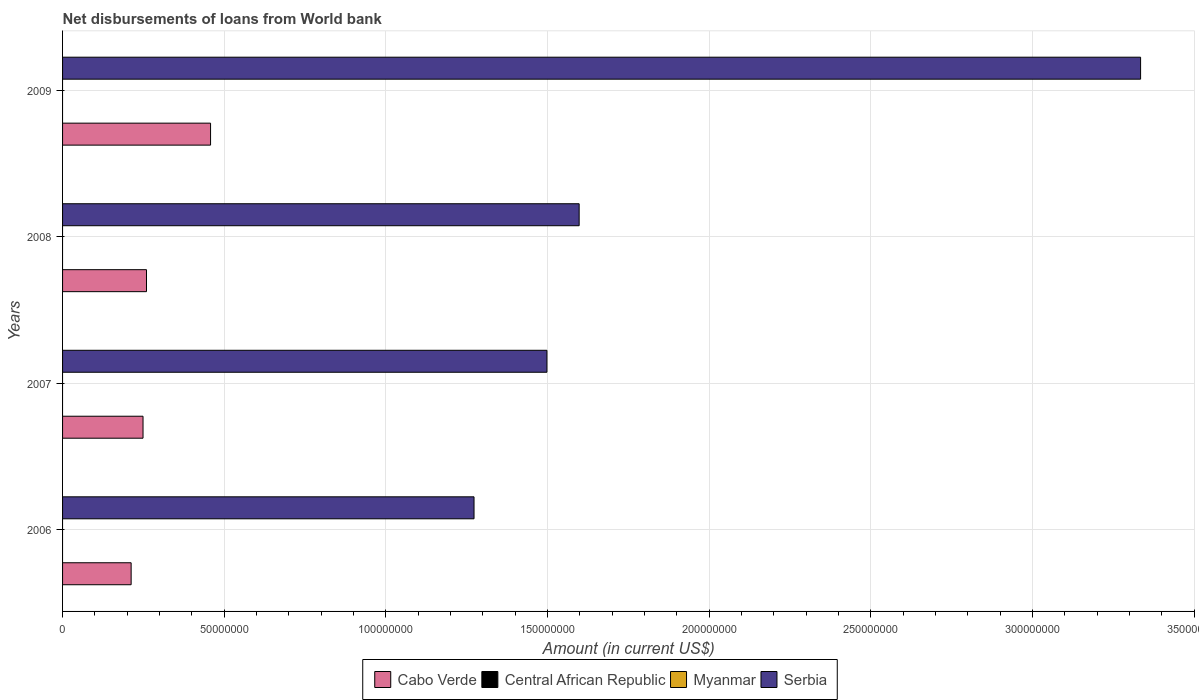Are the number of bars per tick equal to the number of legend labels?
Keep it short and to the point. No. Are the number of bars on each tick of the Y-axis equal?
Provide a succinct answer. Yes. How many bars are there on the 2nd tick from the bottom?
Your response must be concise. 2. What is the label of the 4th group of bars from the top?
Your answer should be very brief. 2006. What is the amount of loan disbursed from World Bank in Central African Republic in 2008?
Give a very brief answer. 0. Across all years, what is the maximum amount of loan disbursed from World Bank in Cabo Verde?
Your response must be concise. 4.58e+07. In which year was the amount of loan disbursed from World Bank in Serbia maximum?
Offer a terse response. 2009. What is the total amount of loan disbursed from World Bank in Cabo Verde in the graph?
Give a very brief answer. 1.18e+08. What is the difference between the amount of loan disbursed from World Bank in Serbia in 2007 and that in 2008?
Your answer should be very brief. -9.97e+06. What is the difference between the amount of loan disbursed from World Bank in Cabo Verde in 2006 and the amount of loan disbursed from World Bank in Central African Republic in 2009?
Keep it short and to the point. 2.12e+07. In the year 2009, what is the difference between the amount of loan disbursed from World Bank in Serbia and amount of loan disbursed from World Bank in Cabo Verde?
Offer a terse response. 2.88e+08. What is the ratio of the amount of loan disbursed from World Bank in Cabo Verde in 2007 to that in 2009?
Make the answer very short. 0.54. Is the amount of loan disbursed from World Bank in Serbia in 2008 less than that in 2009?
Your answer should be compact. Yes. Is the difference between the amount of loan disbursed from World Bank in Serbia in 2007 and 2008 greater than the difference between the amount of loan disbursed from World Bank in Cabo Verde in 2007 and 2008?
Your answer should be compact. No. What is the difference between the highest and the second highest amount of loan disbursed from World Bank in Serbia?
Your answer should be very brief. 1.74e+08. What is the difference between the highest and the lowest amount of loan disbursed from World Bank in Cabo Verde?
Ensure brevity in your answer.  2.46e+07. Is it the case that in every year, the sum of the amount of loan disbursed from World Bank in Serbia and amount of loan disbursed from World Bank in Myanmar is greater than the amount of loan disbursed from World Bank in Cabo Verde?
Give a very brief answer. Yes. How many bars are there?
Ensure brevity in your answer.  8. How many years are there in the graph?
Your answer should be very brief. 4. What is the difference between two consecutive major ticks on the X-axis?
Provide a short and direct response. 5.00e+07. Are the values on the major ticks of X-axis written in scientific E-notation?
Your answer should be compact. No. Does the graph contain any zero values?
Provide a short and direct response. Yes. Where does the legend appear in the graph?
Provide a succinct answer. Bottom center. How are the legend labels stacked?
Your answer should be very brief. Horizontal. What is the title of the graph?
Offer a very short reply. Net disbursements of loans from World bank. Does "French Polynesia" appear as one of the legend labels in the graph?
Your answer should be very brief. No. What is the label or title of the X-axis?
Offer a terse response. Amount (in current US$). What is the Amount (in current US$) of Cabo Verde in 2006?
Give a very brief answer. 2.12e+07. What is the Amount (in current US$) in Central African Republic in 2006?
Offer a terse response. 0. What is the Amount (in current US$) of Myanmar in 2006?
Provide a short and direct response. 0. What is the Amount (in current US$) in Serbia in 2006?
Give a very brief answer. 1.27e+08. What is the Amount (in current US$) in Cabo Verde in 2007?
Your answer should be compact. 2.49e+07. What is the Amount (in current US$) in Myanmar in 2007?
Ensure brevity in your answer.  0. What is the Amount (in current US$) of Serbia in 2007?
Ensure brevity in your answer.  1.50e+08. What is the Amount (in current US$) in Cabo Verde in 2008?
Your response must be concise. 2.60e+07. What is the Amount (in current US$) in Myanmar in 2008?
Your answer should be very brief. 0. What is the Amount (in current US$) of Serbia in 2008?
Your answer should be very brief. 1.60e+08. What is the Amount (in current US$) in Cabo Verde in 2009?
Provide a short and direct response. 4.58e+07. What is the Amount (in current US$) of Serbia in 2009?
Your answer should be compact. 3.33e+08. Across all years, what is the maximum Amount (in current US$) of Cabo Verde?
Provide a succinct answer. 4.58e+07. Across all years, what is the maximum Amount (in current US$) of Serbia?
Give a very brief answer. 3.33e+08. Across all years, what is the minimum Amount (in current US$) in Cabo Verde?
Provide a succinct answer. 2.12e+07. Across all years, what is the minimum Amount (in current US$) of Serbia?
Provide a succinct answer. 1.27e+08. What is the total Amount (in current US$) in Cabo Verde in the graph?
Ensure brevity in your answer.  1.18e+08. What is the total Amount (in current US$) in Myanmar in the graph?
Give a very brief answer. 0. What is the total Amount (in current US$) of Serbia in the graph?
Your answer should be compact. 7.70e+08. What is the difference between the Amount (in current US$) of Cabo Verde in 2006 and that in 2007?
Make the answer very short. -3.68e+06. What is the difference between the Amount (in current US$) in Serbia in 2006 and that in 2007?
Give a very brief answer. -2.25e+07. What is the difference between the Amount (in current US$) of Cabo Verde in 2006 and that in 2008?
Make the answer very short. -4.75e+06. What is the difference between the Amount (in current US$) in Serbia in 2006 and that in 2008?
Keep it short and to the point. -3.25e+07. What is the difference between the Amount (in current US$) of Cabo Verde in 2006 and that in 2009?
Keep it short and to the point. -2.46e+07. What is the difference between the Amount (in current US$) of Serbia in 2006 and that in 2009?
Provide a short and direct response. -2.06e+08. What is the difference between the Amount (in current US$) in Cabo Verde in 2007 and that in 2008?
Ensure brevity in your answer.  -1.08e+06. What is the difference between the Amount (in current US$) in Serbia in 2007 and that in 2008?
Give a very brief answer. -9.97e+06. What is the difference between the Amount (in current US$) in Cabo Verde in 2007 and that in 2009?
Provide a short and direct response. -2.09e+07. What is the difference between the Amount (in current US$) of Serbia in 2007 and that in 2009?
Make the answer very short. -1.84e+08. What is the difference between the Amount (in current US$) in Cabo Verde in 2008 and that in 2009?
Your answer should be very brief. -1.98e+07. What is the difference between the Amount (in current US$) in Serbia in 2008 and that in 2009?
Give a very brief answer. -1.74e+08. What is the difference between the Amount (in current US$) in Cabo Verde in 2006 and the Amount (in current US$) in Serbia in 2007?
Offer a terse response. -1.29e+08. What is the difference between the Amount (in current US$) of Cabo Verde in 2006 and the Amount (in current US$) of Serbia in 2008?
Offer a terse response. -1.39e+08. What is the difference between the Amount (in current US$) in Cabo Verde in 2006 and the Amount (in current US$) in Serbia in 2009?
Keep it short and to the point. -3.12e+08. What is the difference between the Amount (in current US$) of Cabo Verde in 2007 and the Amount (in current US$) of Serbia in 2008?
Provide a succinct answer. -1.35e+08. What is the difference between the Amount (in current US$) of Cabo Verde in 2007 and the Amount (in current US$) of Serbia in 2009?
Offer a terse response. -3.09e+08. What is the difference between the Amount (in current US$) of Cabo Verde in 2008 and the Amount (in current US$) of Serbia in 2009?
Your answer should be very brief. -3.07e+08. What is the average Amount (in current US$) of Cabo Verde per year?
Your answer should be compact. 2.95e+07. What is the average Amount (in current US$) of Myanmar per year?
Give a very brief answer. 0. What is the average Amount (in current US$) in Serbia per year?
Provide a succinct answer. 1.93e+08. In the year 2006, what is the difference between the Amount (in current US$) in Cabo Verde and Amount (in current US$) in Serbia?
Your answer should be compact. -1.06e+08. In the year 2007, what is the difference between the Amount (in current US$) of Cabo Verde and Amount (in current US$) of Serbia?
Give a very brief answer. -1.25e+08. In the year 2008, what is the difference between the Amount (in current US$) in Cabo Verde and Amount (in current US$) in Serbia?
Your answer should be compact. -1.34e+08. In the year 2009, what is the difference between the Amount (in current US$) of Cabo Verde and Amount (in current US$) of Serbia?
Provide a short and direct response. -2.88e+08. What is the ratio of the Amount (in current US$) in Cabo Verde in 2006 to that in 2007?
Provide a short and direct response. 0.85. What is the ratio of the Amount (in current US$) of Serbia in 2006 to that in 2007?
Your answer should be compact. 0.85. What is the ratio of the Amount (in current US$) of Cabo Verde in 2006 to that in 2008?
Make the answer very short. 0.82. What is the ratio of the Amount (in current US$) in Serbia in 2006 to that in 2008?
Ensure brevity in your answer.  0.8. What is the ratio of the Amount (in current US$) of Cabo Verde in 2006 to that in 2009?
Make the answer very short. 0.46. What is the ratio of the Amount (in current US$) of Serbia in 2006 to that in 2009?
Give a very brief answer. 0.38. What is the ratio of the Amount (in current US$) in Cabo Verde in 2007 to that in 2008?
Keep it short and to the point. 0.96. What is the ratio of the Amount (in current US$) of Serbia in 2007 to that in 2008?
Your response must be concise. 0.94. What is the ratio of the Amount (in current US$) in Cabo Verde in 2007 to that in 2009?
Provide a succinct answer. 0.54. What is the ratio of the Amount (in current US$) of Serbia in 2007 to that in 2009?
Your response must be concise. 0.45. What is the ratio of the Amount (in current US$) in Cabo Verde in 2008 to that in 2009?
Provide a short and direct response. 0.57. What is the ratio of the Amount (in current US$) in Serbia in 2008 to that in 2009?
Keep it short and to the point. 0.48. What is the difference between the highest and the second highest Amount (in current US$) of Cabo Verde?
Your answer should be very brief. 1.98e+07. What is the difference between the highest and the second highest Amount (in current US$) in Serbia?
Offer a terse response. 1.74e+08. What is the difference between the highest and the lowest Amount (in current US$) of Cabo Verde?
Offer a terse response. 2.46e+07. What is the difference between the highest and the lowest Amount (in current US$) of Serbia?
Ensure brevity in your answer.  2.06e+08. 